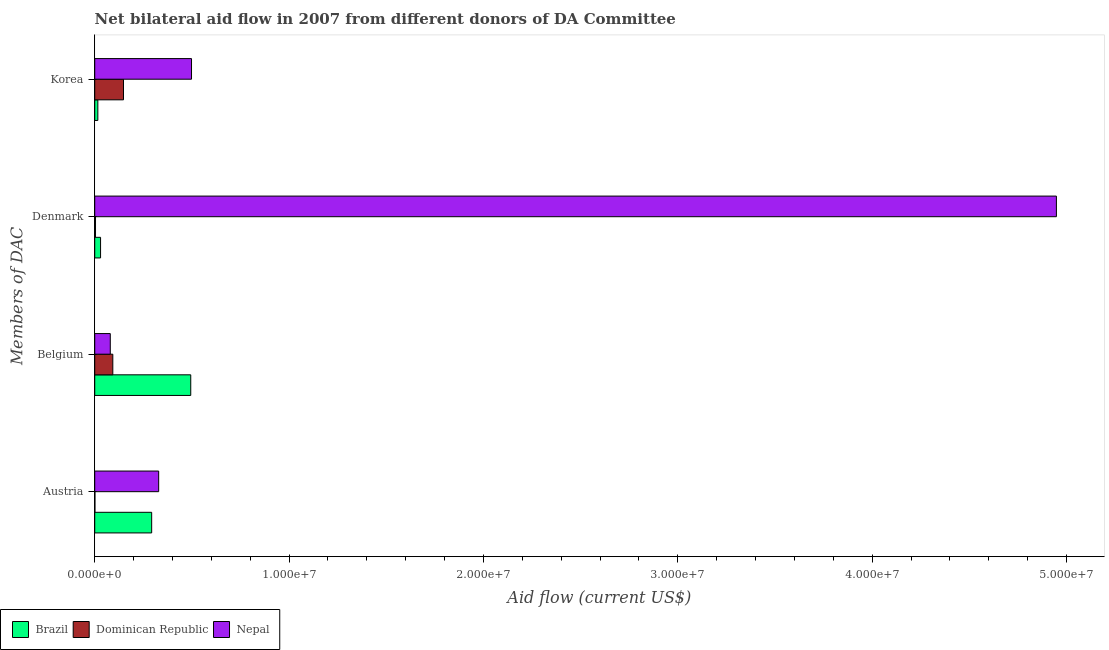How many different coloured bars are there?
Offer a terse response. 3. How many groups of bars are there?
Offer a terse response. 4. Are the number of bars on each tick of the Y-axis equal?
Your answer should be very brief. Yes. How many bars are there on the 1st tick from the top?
Give a very brief answer. 3. What is the label of the 3rd group of bars from the top?
Make the answer very short. Belgium. What is the amount of aid given by denmark in Dominican Republic?
Your answer should be very brief. 4.00e+04. Across all countries, what is the maximum amount of aid given by korea?
Provide a short and direct response. 4.98e+06. Across all countries, what is the minimum amount of aid given by denmark?
Ensure brevity in your answer.  4.00e+04. In which country was the amount of aid given by belgium maximum?
Your answer should be compact. Brazil. In which country was the amount of aid given by denmark minimum?
Give a very brief answer. Dominican Republic. What is the total amount of aid given by denmark in the graph?
Provide a short and direct response. 4.98e+07. What is the difference between the amount of aid given by denmark in Nepal and that in Brazil?
Your answer should be very brief. 4.92e+07. What is the difference between the amount of aid given by austria in Dominican Republic and the amount of aid given by denmark in Nepal?
Give a very brief answer. -4.95e+07. What is the average amount of aid given by denmark per country?
Provide a succinct answer. 1.66e+07. What is the difference between the amount of aid given by austria and amount of aid given by belgium in Dominican Republic?
Your answer should be very brief. -9.20e+05. What is the ratio of the amount of aid given by austria in Nepal to that in Dominican Republic?
Make the answer very short. 329. Is the amount of aid given by korea in Nepal less than that in Brazil?
Keep it short and to the point. No. What is the difference between the highest and the second highest amount of aid given by denmark?
Give a very brief answer. 4.92e+07. What is the difference between the highest and the lowest amount of aid given by austria?
Make the answer very short. 3.28e+06. Is the sum of the amount of aid given by belgium in Nepal and Brazil greater than the maximum amount of aid given by korea across all countries?
Your answer should be very brief. Yes. Is it the case that in every country, the sum of the amount of aid given by korea and amount of aid given by belgium is greater than the sum of amount of aid given by austria and amount of aid given by denmark?
Ensure brevity in your answer.  No. What does the 2nd bar from the top in Denmark represents?
Your response must be concise. Dominican Republic. What does the 2nd bar from the bottom in Korea represents?
Provide a succinct answer. Dominican Republic. How many bars are there?
Ensure brevity in your answer.  12. Are all the bars in the graph horizontal?
Make the answer very short. Yes. How many countries are there in the graph?
Provide a short and direct response. 3. Are the values on the major ticks of X-axis written in scientific E-notation?
Keep it short and to the point. Yes. Does the graph contain any zero values?
Provide a short and direct response. No. What is the title of the graph?
Provide a succinct answer. Net bilateral aid flow in 2007 from different donors of DA Committee. Does "Korea (Republic)" appear as one of the legend labels in the graph?
Provide a succinct answer. No. What is the label or title of the X-axis?
Your answer should be compact. Aid flow (current US$). What is the label or title of the Y-axis?
Provide a succinct answer. Members of DAC. What is the Aid flow (current US$) in Brazil in Austria?
Ensure brevity in your answer.  2.93e+06. What is the Aid flow (current US$) in Nepal in Austria?
Your answer should be very brief. 3.29e+06. What is the Aid flow (current US$) in Brazil in Belgium?
Offer a very short reply. 4.94e+06. What is the Aid flow (current US$) in Dominican Republic in Belgium?
Your answer should be very brief. 9.30e+05. What is the Aid flow (current US$) of Nepal in Denmark?
Provide a short and direct response. 4.95e+07. What is the Aid flow (current US$) in Dominican Republic in Korea?
Your answer should be compact. 1.48e+06. What is the Aid flow (current US$) in Nepal in Korea?
Provide a short and direct response. 4.98e+06. Across all Members of DAC, what is the maximum Aid flow (current US$) of Brazil?
Keep it short and to the point. 4.94e+06. Across all Members of DAC, what is the maximum Aid flow (current US$) of Dominican Republic?
Offer a terse response. 1.48e+06. Across all Members of DAC, what is the maximum Aid flow (current US$) of Nepal?
Your answer should be compact. 4.95e+07. Across all Members of DAC, what is the minimum Aid flow (current US$) in Brazil?
Offer a very short reply. 1.60e+05. Across all Members of DAC, what is the minimum Aid flow (current US$) in Dominican Republic?
Ensure brevity in your answer.  10000. What is the total Aid flow (current US$) in Brazil in the graph?
Keep it short and to the point. 8.33e+06. What is the total Aid flow (current US$) in Dominican Republic in the graph?
Your answer should be very brief. 2.46e+06. What is the total Aid flow (current US$) in Nepal in the graph?
Your response must be concise. 5.86e+07. What is the difference between the Aid flow (current US$) of Brazil in Austria and that in Belgium?
Provide a short and direct response. -2.01e+06. What is the difference between the Aid flow (current US$) of Dominican Republic in Austria and that in Belgium?
Provide a succinct answer. -9.20e+05. What is the difference between the Aid flow (current US$) of Nepal in Austria and that in Belgium?
Make the answer very short. 2.49e+06. What is the difference between the Aid flow (current US$) of Brazil in Austria and that in Denmark?
Offer a very short reply. 2.63e+06. What is the difference between the Aid flow (current US$) of Nepal in Austria and that in Denmark?
Offer a terse response. -4.62e+07. What is the difference between the Aid flow (current US$) of Brazil in Austria and that in Korea?
Your answer should be very brief. 2.77e+06. What is the difference between the Aid flow (current US$) of Dominican Republic in Austria and that in Korea?
Your answer should be very brief. -1.47e+06. What is the difference between the Aid flow (current US$) in Nepal in Austria and that in Korea?
Keep it short and to the point. -1.69e+06. What is the difference between the Aid flow (current US$) in Brazil in Belgium and that in Denmark?
Provide a short and direct response. 4.64e+06. What is the difference between the Aid flow (current US$) in Dominican Republic in Belgium and that in Denmark?
Ensure brevity in your answer.  8.90e+05. What is the difference between the Aid flow (current US$) in Nepal in Belgium and that in Denmark?
Offer a very short reply. -4.87e+07. What is the difference between the Aid flow (current US$) of Brazil in Belgium and that in Korea?
Offer a terse response. 4.78e+06. What is the difference between the Aid flow (current US$) of Dominican Republic in Belgium and that in Korea?
Your response must be concise. -5.50e+05. What is the difference between the Aid flow (current US$) in Nepal in Belgium and that in Korea?
Make the answer very short. -4.18e+06. What is the difference between the Aid flow (current US$) of Dominican Republic in Denmark and that in Korea?
Provide a succinct answer. -1.44e+06. What is the difference between the Aid flow (current US$) of Nepal in Denmark and that in Korea?
Provide a succinct answer. 4.45e+07. What is the difference between the Aid flow (current US$) in Brazil in Austria and the Aid flow (current US$) in Dominican Republic in Belgium?
Give a very brief answer. 2.00e+06. What is the difference between the Aid flow (current US$) in Brazil in Austria and the Aid flow (current US$) in Nepal in Belgium?
Your response must be concise. 2.13e+06. What is the difference between the Aid flow (current US$) in Dominican Republic in Austria and the Aid flow (current US$) in Nepal in Belgium?
Provide a succinct answer. -7.90e+05. What is the difference between the Aid flow (current US$) of Brazil in Austria and the Aid flow (current US$) of Dominican Republic in Denmark?
Provide a succinct answer. 2.89e+06. What is the difference between the Aid flow (current US$) in Brazil in Austria and the Aid flow (current US$) in Nepal in Denmark?
Your response must be concise. -4.66e+07. What is the difference between the Aid flow (current US$) of Dominican Republic in Austria and the Aid flow (current US$) of Nepal in Denmark?
Offer a terse response. -4.95e+07. What is the difference between the Aid flow (current US$) in Brazil in Austria and the Aid flow (current US$) in Dominican Republic in Korea?
Provide a short and direct response. 1.45e+06. What is the difference between the Aid flow (current US$) in Brazil in Austria and the Aid flow (current US$) in Nepal in Korea?
Ensure brevity in your answer.  -2.05e+06. What is the difference between the Aid flow (current US$) of Dominican Republic in Austria and the Aid flow (current US$) of Nepal in Korea?
Give a very brief answer. -4.97e+06. What is the difference between the Aid flow (current US$) in Brazil in Belgium and the Aid flow (current US$) in Dominican Republic in Denmark?
Your answer should be very brief. 4.90e+06. What is the difference between the Aid flow (current US$) of Brazil in Belgium and the Aid flow (current US$) of Nepal in Denmark?
Your answer should be compact. -4.45e+07. What is the difference between the Aid flow (current US$) of Dominican Republic in Belgium and the Aid flow (current US$) of Nepal in Denmark?
Offer a very short reply. -4.86e+07. What is the difference between the Aid flow (current US$) in Brazil in Belgium and the Aid flow (current US$) in Dominican Republic in Korea?
Keep it short and to the point. 3.46e+06. What is the difference between the Aid flow (current US$) of Brazil in Belgium and the Aid flow (current US$) of Nepal in Korea?
Give a very brief answer. -4.00e+04. What is the difference between the Aid flow (current US$) of Dominican Republic in Belgium and the Aid flow (current US$) of Nepal in Korea?
Provide a short and direct response. -4.05e+06. What is the difference between the Aid flow (current US$) of Brazil in Denmark and the Aid flow (current US$) of Dominican Republic in Korea?
Your answer should be very brief. -1.18e+06. What is the difference between the Aid flow (current US$) in Brazil in Denmark and the Aid flow (current US$) in Nepal in Korea?
Offer a very short reply. -4.68e+06. What is the difference between the Aid flow (current US$) in Dominican Republic in Denmark and the Aid flow (current US$) in Nepal in Korea?
Your response must be concise. -4.94e+06. What is the average Aid flow (current US$) of Brazil per Members of DAC?
Give a very brief answer. 2.08e+06. What is the average Aid flow (current US$) in Dominican Republic per Members of DAC?
Provide a short and direct response. 6.15e+05. What is the average Aid flow (current US$) in Nepal per Members of DAC?
Give a very brief answer. 1.46e+07. What is the difference between the Aid flow (current US$) of Brazil and Aid flow (current US$) of Dominican Republic in Austria?
Provide a succinct answer. 2.92e+06. What is the difference between the Aid flow (current US$) in Brazil and Aid flow (current US$) in Nepal in Austria?
Your answer should be compact. -3.60e+05. What is the difference between the Aid flow (current US$) in Dominican Republic and Aid flow (current US$) in Nepal in Austria?
Your response must be concise. -3.28e+06. What is the difference between the Aid flow (current US$) in Brazil and Aid flow (current US$) in Dominican Republic in Belgium?
Make the answer very short. 4.01e+06. What is the difference between the Aid flow (current US$) of Brazil and Aid flow (current US$) of Nepal in Belgium?
Keep it short and to the point. 4.14e+06. What is the difference between the Aid flow (current US$) in Dominican Republic and Aid flow (current US$) in Nepal in Belgium?
Offer a very short reply. 1.30e+05. What is the difference between the Aid flow (current US$) of Brazil and Aid flow (current US$) of Dominican Republic in Denmark?
Offer a very short reply. 2.60e+05. What is the difference between the Aid flow (current US$) of Brazil and Aid flow (current US$) of Nepal in Denmark?
Give a very brief answer. -4.92e+07. What is the difference between the Aid flow (current US$) in Dominican Republic and Aid flow (current US$) in Nepal in Denmark?
Your response must be concise. -4.94e+07. What is the difference between the Aid flow (current US$) of Brazil and Aid flow (current US$) of Dominican Republic in Korea?
Keep it short and to the point. -1.32e+06. What is the difference between the Aid flow (current US$) of Brazil and Aid flow (current US$) of Nepal in Korea?
Offer a very short reply. -4.82e+06. What is the difference between the Aid flow (current US$) in Dominican Republic and Aid flow (current US$) in Nepal in Korea?
Your answer should be compact. -3.50e+06. What is the ratio of the Aid flow (current US$) of Brazil in Austria to that in Belgium?
Your answer should be very brief. 0.59. What is the ratio of the Aid flow (current US$) of Dominican Republic in Austria to that in Belgium?
Offer a terse response. 0.01. What is the ratio of the Aid flow (current US$) of Nepal in Austria to that in Belgium?
Provide a succinct answer. 4.11. What is the ratio of the Aid flow (current US$) in Brazil in Austria to that in Denmark?
Your answer should be very brief. 9.77. What is the ratio of the Aid flow (current US$) of Dominican Republic in Austria to that in Denmark?
Your answer should be very brief. 0.25. What is the ratio of the Aid flow (current US$) of Nepal in Austria to that in Denmark?
Ensure brevity in your answer.  0.07. What is the ratio of the Aid flow (current US$) of Brazil in Austria to that in Korea?
Your answer should be compact. 18.31. What is the ratio of the Aid flow (current US$) in Dominican Republic in Austria to that in Korea?
Give a very brief answer. 0.01. What is the ratio of the Aid flow (current US$) in Nepal in Austria to that in Korea?
Offer a terse response. 0.66. What is the ratio of the Aid flow (current US$) of Brazil in Belgium to that in Denmark?
Give a very brief answer. 16.47. What is the ratio of the Aid flow (current US$) of Dominican Republic in Belgium to that in Denmark?
Give a very brief answer. 23.25. What is the ratio of the Aid flow (current US$) of Nepal in Belgium to that in Denmark?
Your answer should be very brief. 0.02. What is the ratio of the Aid flow (current US$) of Brazil in Belgium to that in Korea?
Your response must be concise. 30.88. What is the ratio of the Aid flow (current US$) of Dominican Republic in Belgium to that in Korea?
Ensure brevity in your answer.  0.63. What is the ratio of the Aid flow (current US$) in Nepal in Belgium to that in Korea?
Your answer should be compact. 0.16. What is the ratio of the Aid flow (current US$) of Brazil in Denmark to that in Korea?
Make the answer very short. 1.88. What is the ratio of the Aid flow (current US$) in Dominican Republic in Denmark to that in Korea?
Keep it short and to the point. 0.03. What is the ratio of the Aid flow (current US$) of Nepal in Denmark to that in Korea?
Make the answer very short. 9.94. What is the difference between the highest and the second highest Aid flow (current US$) in Brazil?
Provide a succinct answer. 2.01e+06. What is the difference between the highest and the second highest Aid flow (current US$) of Nepal?
Your answer should be compact. 4.45e+07. What is the difference between the highest and the lowest Aid flow (current US$) in Brazil?
Keep it short and to the point. 4.78e+06. What is the difference between the highest and the lowest Aid flow (current US$) in Dominican Republic?
Offer a terse response. 1.47e+06. What is the difference between the highest and the lowest Aid flow (current US$) of Nepal?
Provide a short and direct response. 4.87e+07. 